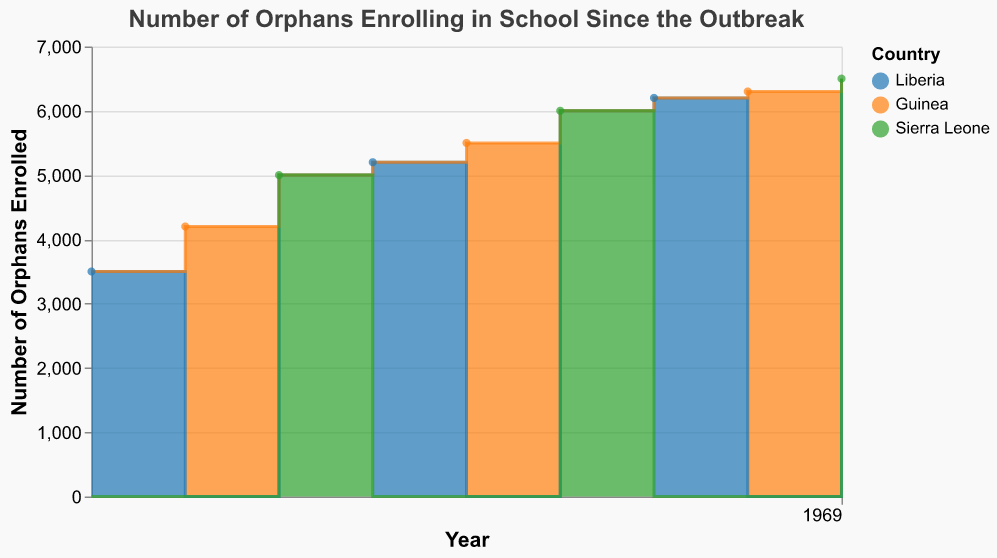What is the title of the chart? The title is usually placed at the top of the chart and is the largest and most prominent text, indicating the main subject.
Answer: Number of Orphans Enrolling in School Since the Outbreak Which year had the lowest number of orphans enrolled in school? Identify the bar with the smallest height or position closest to the baseline on the vertical axis.
Answer: 2014 What are the three countries represented in the chart? Look at the legend or different colored segments in the chart that correspond to each country.
Answer: Liberia, Guinea, Sierra Leone How many orphans enrolled in school in 2019 in Sierra Leone? Find the data point corresponding to the year 2019 and look at the vertical axis value for Sierra Leone.
Answer: 6000 What is the general trend in the number of orphans enrolling in schools from 2014 to 2022? Observe how the height of the areas increases or decreases over the timeline on the horizontal axis.
Answer: Increasing Which country showed the highest number of orphans enrolled in any year within the dataset? Identify the tallest step or area segment and read the tooltip or legend for the country.
Answer: Sierra Leone (2022 with 6500) Between Liberia and Guinea, which country had more orphans enrolled in 2018? Compare the height of the segments in the year 2018 for both countries.
Answer: Guinea How does the number of orphans enrolled in 2020 in Liberia compare to 2017 in the same country? Look at the step heights for the specified years and compare the values.
Answer: 2020 is higher (6200 vs 5200) Calculate the average number of orphans enrolled in Liberia over the years shown. Sum the enrollment numbers for Liberia (3500 + 5200 + 6200) and divide by the number of years Liberia is recorded.
Answer: 4966.67 Determine the percentage increase in the number of orphans enrolled in Guinea from 2015 to 2021. ((6300 - 4200) / 4200) * 100 to find the percentage change.
Answer: 50% 